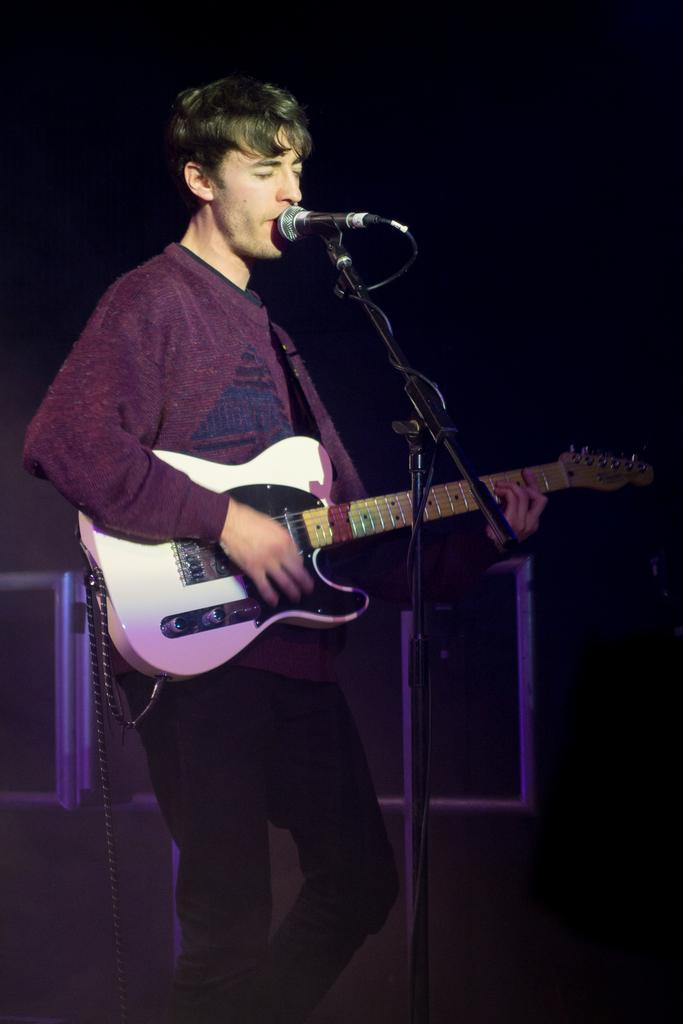What is the main subject of the image? The main subject of the image is a man. What is the man doing in the image? The man is standing in the image. What object is the man holding? The man is holding a guitar. What is in front of the man? There is a microphone in front of the man. What type of poison is the man using to play the guitar in the image? There is no poison present in the image, and the man is not using any poison to play the guitar. Can you tell me what kind of badge the man is wearing in the image? There is no badge visible in the image. 